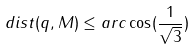<formula> <loc_0><loc_0><loc_500><loc_500>d i s t ( q , M ) \leq a r c \cos ( \frac { 1 } { \sqrt { 3 } } )</formula> 